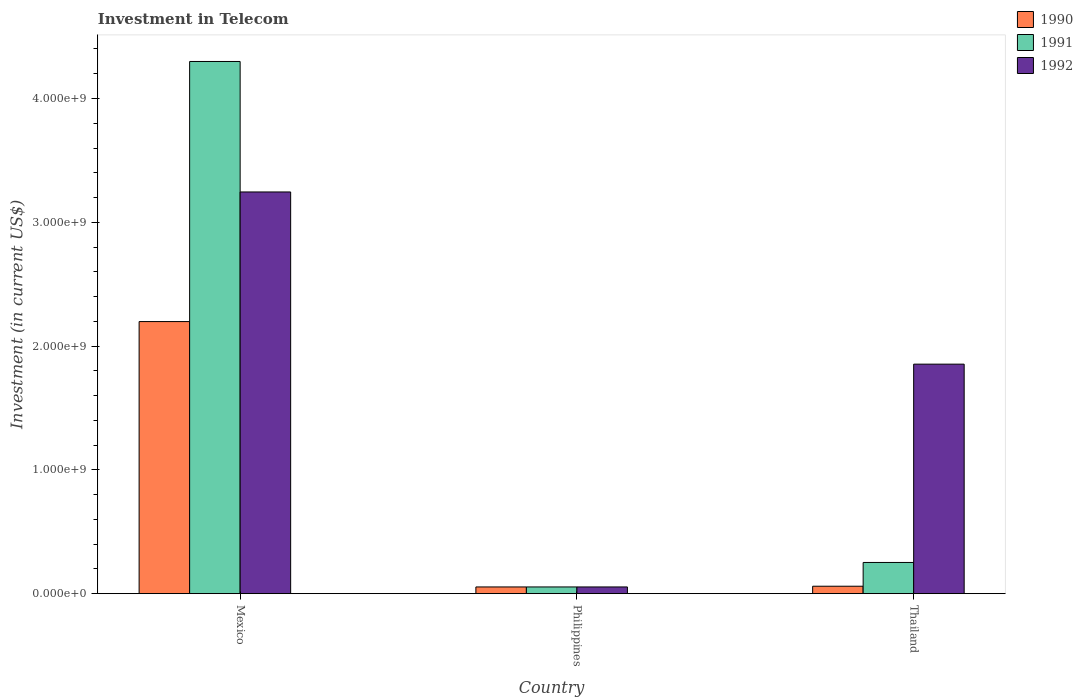How many bars are there on the 1st tick from the left?
Keep it short and to the point. 3. How many bars are there on the 1st tick from the right?
Ensure brevity in your answer.  3. What is the amount invested in telecom in 1990 in Thailand?
Offer a terse response. 6.00e+07. Across all countries, what is the maximum amount invested in telecom in 1990?
Your response must be concise. 2.20e+09. Across all countries, what is the minimum amount invested in telecom in 1991?
Offer a very short reply. 5.42e+07. In which country was the amount invested in telecom in 1991 maximum?
Ensure brevity in your answer.  Mexico. What is the total amount invested in telecom in 1990 in the graph?
Offer a very short reply. 2.31e+09. What is the difference between the amount invested in telecom in 1991 in Mexico and that in Thailand?
Give a very brief answer. 4.05e+09. What is the difference between the amount invested in telecom in 1991 in Thailand and the amount invested in telecom in 1992 in Philippines?
Make the answer very short. 1.98e+08. What is the average amount invested in telecom in 1992 per country?
Ensure brevity in your answer.  1.72e+09. What is the difference between the amount invested in telecom of/in 1992 and amount invested in telecom of/in 1991 in Mexico?
Offer a very short reply. -1.05e+09. In how many countries, is the amount invested in telecom in 1990 greater than 4000000000 US$?
Provide a short and direct response. 0. What is the ratio of the amount invested in telecom in 1992 in Philippines to that in Thailand?
Provide a short and direct response. 0.03. Is the difference between the amount invested in telecom in 1992 in Mexico and Thailand greater than the difference between the amount invested in telecom in 1991 in Mexico and Thailand?
Make the answer very short. No. What is the difference between the highest and the second highest amount invested in telecom in 1992?
Your answer should be compact. 1.39e+09. What is the difference between the highest and the lowest amount invested in telecom in 1991?
Offer a very short reply. 4.24e+09. Is the sum of the amount invested in telecom in 1991 in Mexico and Thailand greater than the maximum amount invested in telecom in 1990 across all countries?
Make the answer very short. Yes. What does the 1st bar from the left in Mexico represents?
Your answer should be compact. 1990. Is it the case that in every country, the sum of the amount invested in telecom in 1992 and amount invested in telecom in 1990 is greater than the amount invested in telecom in 1991?
Your answer should be compact. Yes. How many bars are there?
Ensure brevity in your answer.  9. How many countries are there in the graph?
Offer a terse response. 3. Are the values on the major ticks of Y-axis written in scientific E-notation?
Your response must be concise. Yes. Does the graph contain any zero values?
Give a very brief answer. No. How many legend labels are there?
Make the answer very short. 3. How are the legend labels stacked?
Offer a terse response. Vertical. What is the title of the graph?
Your response must be concise. Investment in Telecom. What is the label or title of the Y-axis?
Provide a succinct answer. Investment (in current US$). What is the Investment (in current US$) of 1990 in Mexico?
Offer a terse response. 2.20e+09. What is the Investment (in current US$) in 1991 in Mexico?
Offer a terse response. 4.30e+09. What is the Investment (in current US$) in 1992 in Mexico?
Offer a very short reply. 3.24e+09. What is the Investment (in current US$) of 1990 in Philippines?
Your answer should be compact. 5.42e+07. What is the Investment (in current US$) of 1991 in Philippines?
Provide a short and direct response. 5.42e+07. What is the Investment (in current US$) in 1992 in Philippines?
Ensure brevity in your answer.  5.42e+07. What is the Investment (in current US$) of 1990 in Thailand?
Provide a succinct answer. 6.00e+07. What is the Investment (in current US$) in 1991 in Thailand?
Provide a short and direct response. 2.52e+08. What is the Investment (in current US$) in 1992 in Thailand?
Offer a very short reply. 1.85e+09. Across all countries, what is the maximum Investment (in current US$) in 1990?
Give a very brief answer. 2.20e+09. Across all countries, what is the maximum Investment (in current US$) of 1991?
Offer a very short reply. 4.30e+09. Across all countries, what is the maximum Investment (in current US$) of 1992?
Provide a short and direct response. 3.24e+09. Across all countries, what is the minimum Investment (in current US$) of 1990?
Ensure brevity in your answer.  5.42e+07. Across all countries, what is the minimum Investment (in current US$) of 1991?
Keep it short and to the point. 5.42e+07. Across all countries, what is the minimum Investment (in current US$) of 1992?
Provide a succinct answer. 5.42e+07. What is the total Investment (in current US$) of 1990 in the graph?
Your answer should be very brief. 2.31e+09. What is the total Investment (in current US$) in 1991 in the graph?
Ensure brevity in your answer.  4.61e+09. What is the total Investment (in current US$) of 1992 in the graph?
Offer a very short reply. 5.15e+09. What is the difference between the Investment (in current US$) of 1990 in Mexico and that in Philippines?
Make the answer very short. 2.14e+09. What is the difference between the Investment (in current US$) of 1991 in Mexico and that in Philippines?
Ensure brevity in your answer.  4.24e+09. What is the difference between the Investment (in current US$) in 1992 in Mexico and that in Philippines?
Provide a short and direct response. 3.19e+09. What is the difference between the Investment (in current US$) in 1990 in Mexico and that in Thailand?
Ensure brevity in your answer.  2.14e+09. What is the difference between the Investment (in current US$) of 1991 in Mexico and that in Thailand?
Provide a succinct answer. 4.05e+09. What is the difference between the Investment (in current US$) of 1992 in Mexico and that in Thailand?
Give a very brief answer. 1.39e+09. What is the difference between the Investment (in current US$) of 1990 in Philippines and that in Thailand?
Your response must be concise. -5.80e+06. What is the difference between the Investment (in current US$) in 1991 in Philippines and that in Thailand?
Give a very brief answer. -1.98e+08. What is the difference between the Investment (in current US$) in 1992 in Philippines and that in Thailand?
Ensure brevity in your answer.  -1.80e+09. What is the difference between the Investment (in current US$) in 1990 in Mexico and the Investment (in current US$) in 1991 in Philippines?
Your answer should be very brief. 2.14e+09. What is the difference between the Investment (in current US$) of 1990 in Mexico and the Investment (in current US$) of 1992 in Philippines?
Keep it short and to the point. 2.14e+09. What is the difference between the Investment (in current US$) of 1991 in Mexico and the Investment (in current US$) of 1992 in Philippines?
Your response must be concise. 4.24e+09. What is the difference between the Investment (in current US$) in 1990 in Mexico and the Investment (in current US$) in 1991 in Thailand?
Your response must be concise. 1.95e+09. What is the difference between the Investment (in current US$) of 1990 in Mexico and the Investment (in current US$) of 1992 in Thailand?
Offer a very short reply. 3.44e+08. What is the difference between the Investment (in current US$) of 1991 in Mexico and the Investment (in current US$) of 1992 in Thailand?
Make the answer very short. 2.44e+09. What is the difference between the Investment (in current US$) of 1990 in Philippines and the Investment (in current US$) of 1991 in Thailand?
Keep it short and to the point. -1.98e+08. What is the difference between the Investment (in current US$) in 1990 in Philippines and the Investment (in current US$) in 1992 in Thailand?
Offer a very short reply. -1.80e+09. What is the difference between the Investment (in current US$) in 1991 in Philippines and the Investment (in current US$) in 1992 in Thailand?
Offer a very short reply. -1.80e+09. What is the average Investment (in current US$) of 1990 per country?
Keep it short and to the point. 7.71e+08. What is the average Investment (in current US$) of 1991 per country?
Make the answer very short. 1.54e+09. What is the average Investment (in current US$) of 1992 per country?
Offer a very short reply. 1.72e+09. What is the difference between the Investment (in current US$) of 1990 and Investment (in current US$) of 1991 in Mexico?
Give a very brief answer. -2.10e+09. What is the difference between the Investment (in current US$) in 1990 and Investment (in current US$) in 1992 in Mexico?
Offer a terse response. -1.05e+09. What is the difference between the Investment (in current US$) of 1991 and Investment (in current US$) of 1992 in Mexico?
Ensure brevity in your answer.  1.05e+09. What is the difference between the Investment (in current US$) of 1990 and Investment (in current US$) of 1991 in Philippines?
Your answer should be very brief. 0. What is the difference between the Investment (in current US$) in 1990 and Investment (in current US$) in 1992 in Philippines?
Your answer should be compact. 0. What is the difference between the Investment (in current US$) in 1991 and Investment (in current US$) in 1992 in Philippines?
Keep it short and to the point. 0. What is the difference between the Investment (in current US$) in 1990 and Investment (in current US$) in 1991 in Thailand?
Ensure brevity in your answer.  -1.92e+08. What is the difference between the Investment (in current US$) in 1990 and Investment (in current US$) in 1992 in Thailand?
Your answer should be compact. -1.79e+09. What is the difference between the Investment (in current US$) in 1991 and Investment (in current US$) in 1992 in Thailand?
Make the answer very short. -1.60e+09. What is the ratio of the Investment (in current US$) of 1990 in Mexico to that in Philippines?
Offer a terse response. 40.55. What is the ratio of the Investment (in current US$) in 1991 in Mexico to that in Philippines?
Provide a short and direct response. 79.32. What is the ratio of the Investment (in current US$) of 1992 in Mexico to that in Philippines?
Your answer should be very brief. 59.87. What is the ratio of the Investment (in current US$) of 1990 in Mexico to that in Thailand?
Your answer should be very brief. 36.63. What is the ratio of the Investment (in current US$) in 1991 in Mexico to that in Thailand?
Provide a succinct answer. 17.06. What is the ratio of the Investment (in current US$) in 1992 in Mexico to that in Thailand?
Your answer should be compact. 1.75. What is the ratio of the Investment (in current US$) in 1990 in Philippines to that in Thailand?
Ensure brevity in your answer.  0.9. What is the ratio of the Investment (in current US$) in 1991 in Philippines to that in Thailand?
Offer a terse response. 0.22. What is the ratio of the Investment (in current US$) in 1992 in Philippines to that in Thailand?
Provide a short and direct response. 0.03. What is the difference between the highest and the second highest Investment (in current US$) in 1990?
Ensure brevity in your answer.  2.14e+09. What is the difference between the highest and the second highest Investment (in current US$) of 1991?
Your answer should be compact. 4.05e+09. What is the difference between the highest and the second highest Investment (in current US$) in 1992?
Make the answer very short. 1.39e+09. What is the difference between the highest and the lowest Investment (in current US$) of 1990?
Offer a very short reply. 2.14e+09. What is the difference between the highest and the lowest Investment (in current US$) in 1991?
Offer a very short reply. 4.24e+09. What is the difference between the highest and the lowest Investment (in current US$) of 1992?
Provide a short and direct response. 3.19e+09. 